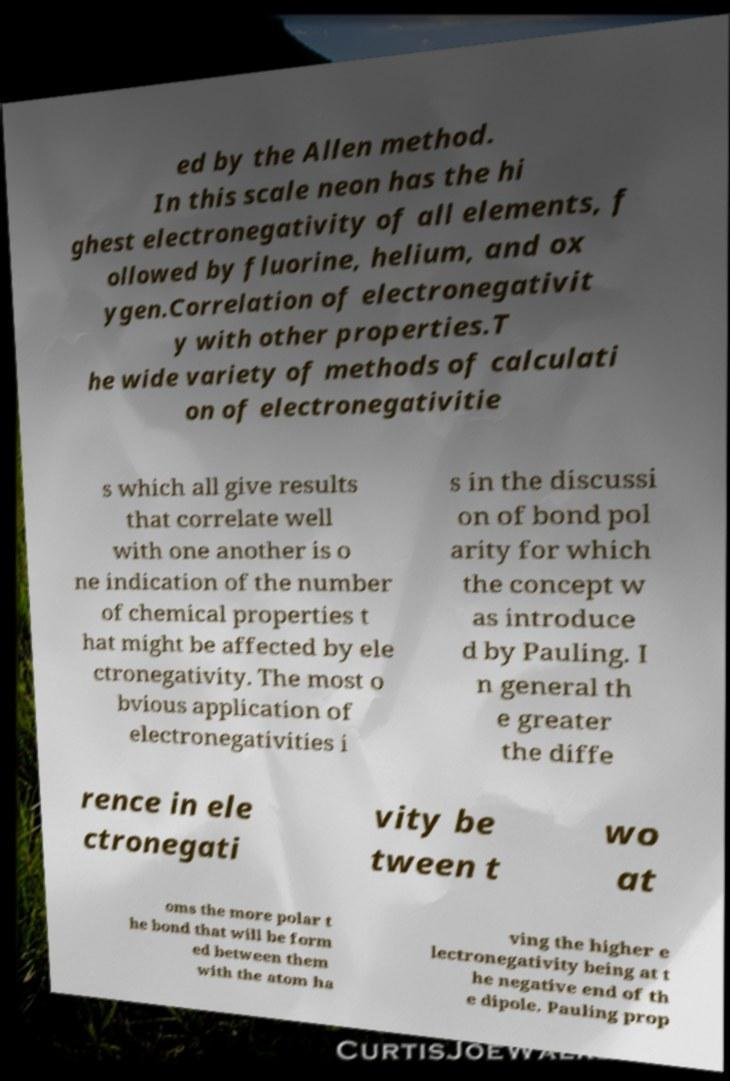For documentation purposes, I need the text within this image transcribed. Could you provide that? ed by the Allen method. In this scale neon has the hi ghest electronegativity of all elements, f ollowed by fluorine, helium, and ox ygen.Correlation of electronegativit y with other properties.T he wide variety of methods of calculati on of electronegativitie s which all give results that correlate well with one another is o ne indication of the number of chemical properties t hat might be affected by ele ctronegativity. The most o bvious application of electronegativities i s in the discussi on of bond pol arity for which the concept w as introduce d by Pauling. I n general th e greater the diffe rence in ele ctronegati vity be tween t wo at oms the more polar t he bond that will be form ed between them with the atom ha ving the higher e lectronegativity being at t he negative end of th e dipole. Pauling prop 